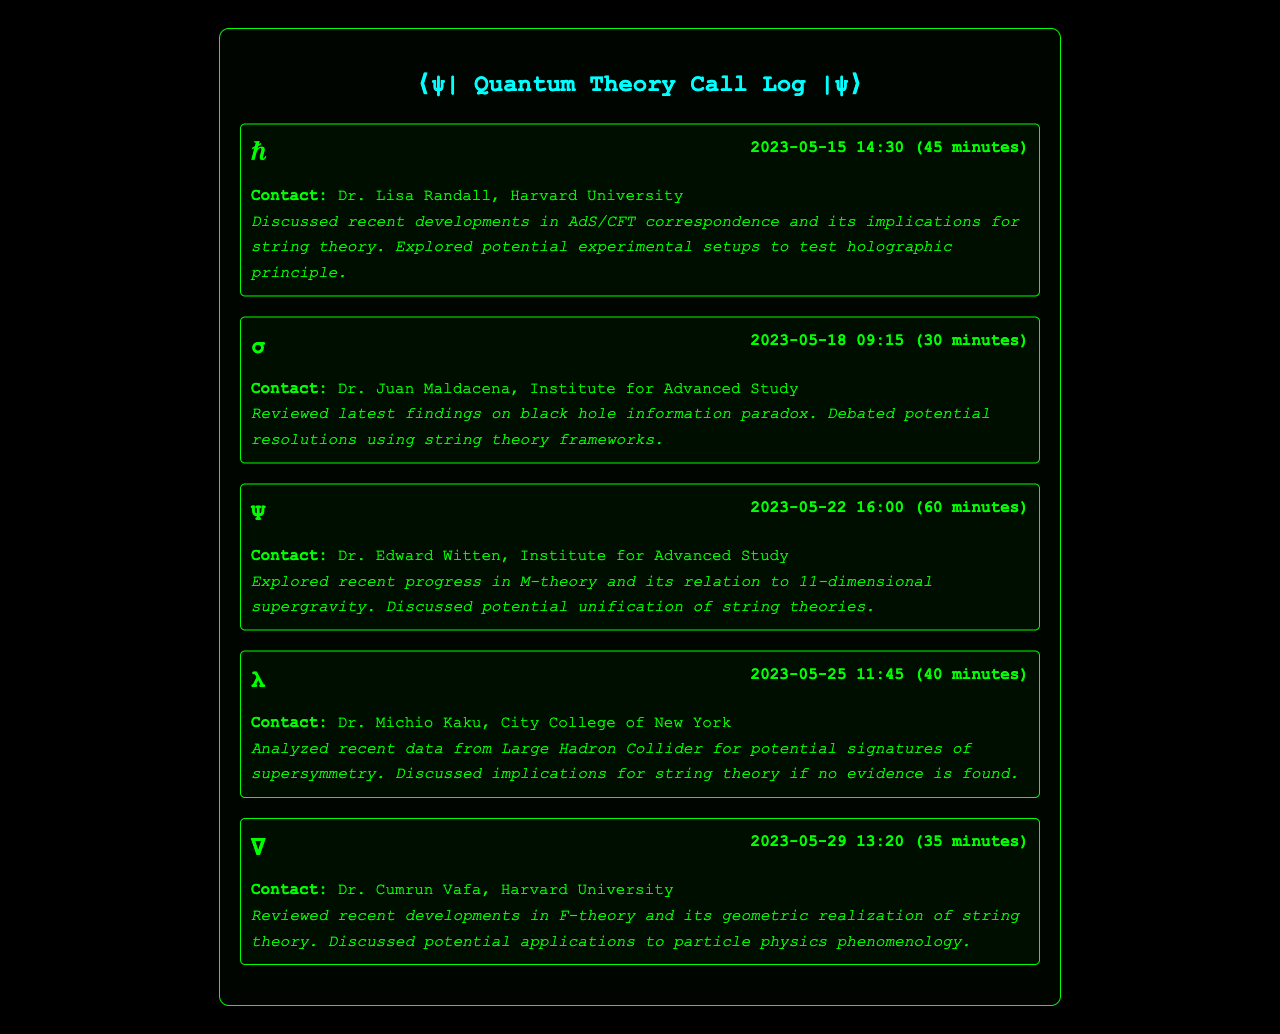What was the date of the first call? The first call was on May 15, 2023, as shown in the call log section of the document.
Answer: May 15, 2023 Who was the contact for the call on May 22? The call on May 22 was with Dr. Edward Witten, identified in the call log.
Answer: Dr. Edward Witten How long was the discussion with Dr. Michio Kaku? The duration of the call with Dr. Michio Kaku on May 25, 2023, is indicated as 40 minutes.
Answer: 40 minutes What topic was debated during the call with Dr. Juan Maldacena? The call with Dr. Juan Maldacena discussed the black hole information paradox, which is mentioned in the call notes.
Answer: Black hole information paradox Which principle was explored in the first call? The first call discussed the holographic principle, noted in the call notes for the meeting with Dr. Lisa Randall.
Answer: Holographic principle What recent advancements were discussed with Dr. Cumrun Vafa? The discussion with Dr. Cumrun Vafa involved F-theory and its geometric realization of string theory.
Answer: F-theory When did the call discussing potential signatures of supersymmetry take place? The call analyzing supersymmetry signatures occurred on May 25, 2023, as listed in the call log.
Answer: May 25, 2023 How many minutes was the call with Dr. Juan Maldacena? The call with Dr. Juan Maldacena lasted 30 minutes, as specified in the duration field.
Answer: 30 minutes What institution is Dr. Lisa Randall associated with? Dr. Lisa Randall is affiliated with Harvard University, which is noted in her contact details.
Answer: Harvard University 